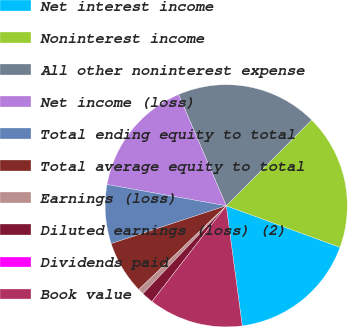Convert chart. <chart><loc_0><loc_0><loc_500><loc_500><pie_chart><fcel>Net interest income<fcel>Noninterest income<fcel>All other noninterest expense<fcel>Net income (loss)<fcel>Total ending equity to total<fcel>Total average equity to total<fcel>Earnings (loss)<fcel>Diluted earnings (loss) (2)<fcel>Dividends paid<fcel>Book value<nl><fcel>17.32%<fcel>18.11%<fcel>18.9%<fcel>15.75%<fcel>7.87%<fcel>7.09%<fcel>0.79%<fcel>1.57%<fcel>0.0%<fcel>12.6%<nl></chart> 